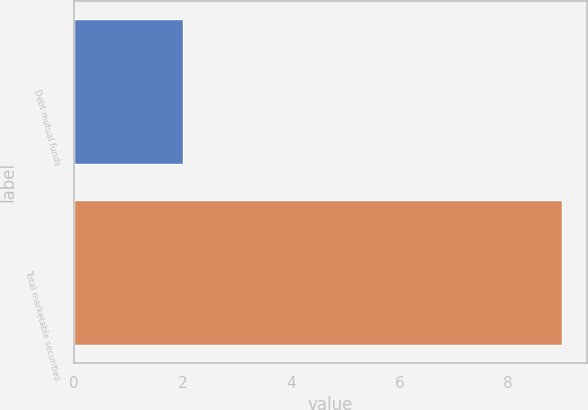Convert chart. <chart><loc_0><loc_0><loc_500><loc_500><bar_chart><fcel>Debt mutual funds<fcel>Total marketable securities<nl><fcel>2<fcel>9<nl></chart> 